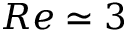<formula> <loc_0><loc_0><loc_500><loc_500>R e \simeq 3</formula> 